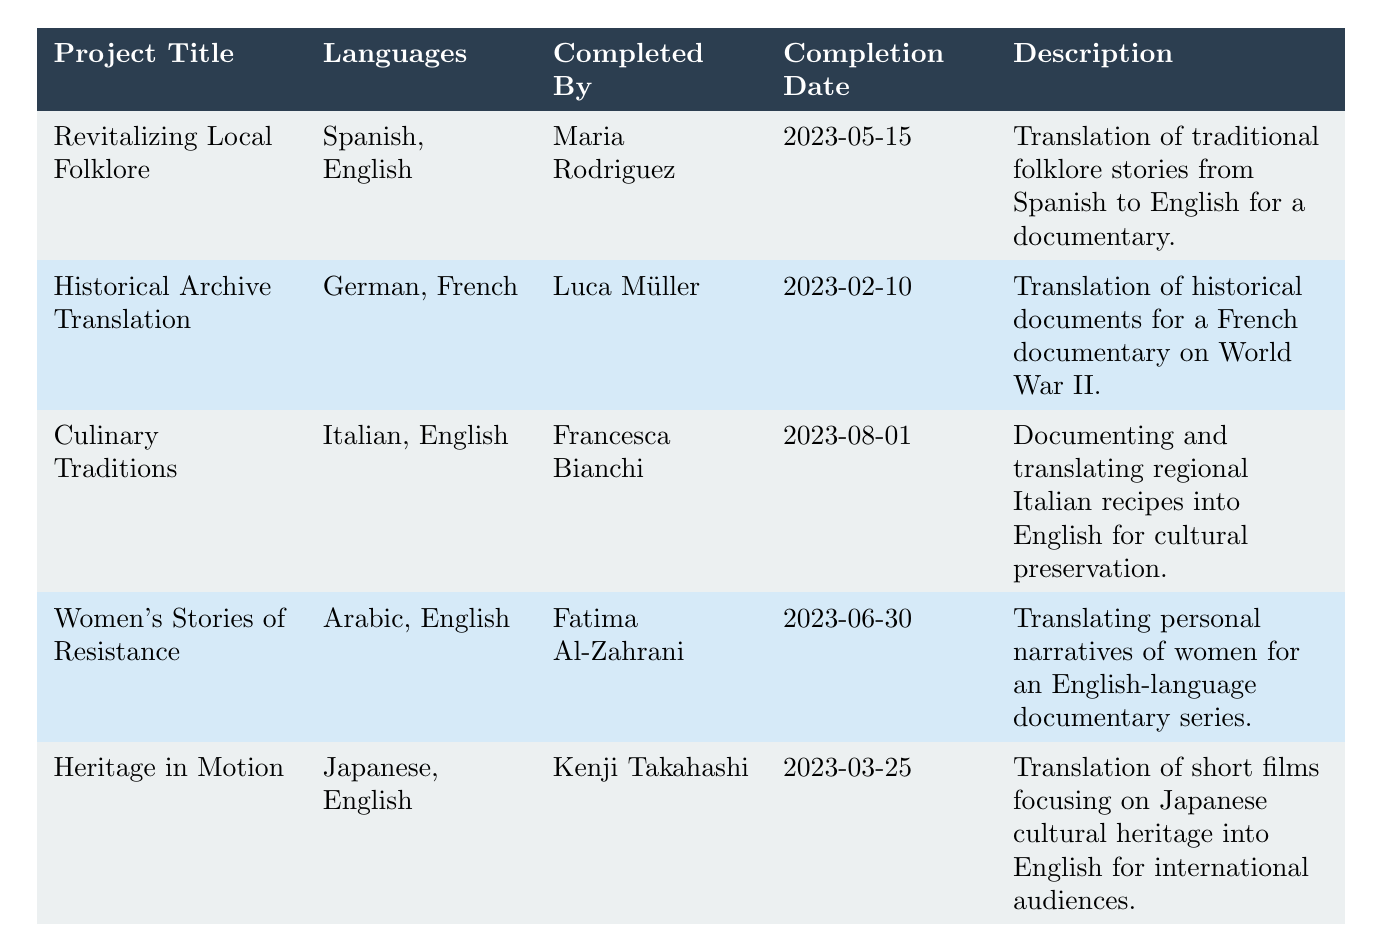What is the title of the project completed by Maria Rodriguez? The table lists the projects and the person who completed them. Maria Rodriguez's project is titled "Revitalizing Local Folklore," as indicated in her corresponding row.
Answer: Revitalizing Local Folklore How many translation projects involved translating into English? By examining the "Languages" column, we can count the projects that include "English" in their list. The relevant projects are "Revitalizing Local Folklore," "Culinary Traditions," "Women's Stories of Resistance," and "Heritage in Motion," totaling four projects.
Answer: 4 Was there a project that included both German and French translations? The table indicates that "Historical Archive Translation" included both German and French languages. This confirms that there was indeed a project translating into both of these languages.
Answer: Yes Who completed the "Culinary Traditions" project? Referring to the specific row for the "Culinary Traditions" project, we see that it was completed by Francesca Bianchi.
Answer: Francesca Bianchi Which project was completed most recently? To determine the most recent project, we compare the completion dates: May 15, June 30, August 1, February 10, and March 25. The latest date is August 1, which corresponds to the "Culinary Traditions" project.
Answer: Culinary Traditions How many different language pairs are represented in the table? The distinct language pairs from the table are: Spanish-English, German-French, Italian-English, Arabic-English, and Japanese-English. This is a total of five distinct pairs.
Answer: 5 Did Kenji Takahashi translate any project related to Japanese culture? The project "Heritage in Motion" indicates that Kenji Takahashi translated short films focusing on Japanese cultural heritage, making it true that he worked on a project related to Japanese culture.
Answer: Yes What is the completion date of the "Historical Archive Translation" project? The completion date is directly listed in the row for "Historical Archive Translation," where it shows as February 10, 2023.
Answer: 2023-02-10 List the names of the translators who worked on projects that included English translations. The translators for the projects with English included are Maria Rodriguez, Francesca Bianchi, Fatima Al-Zahrani, and Kenji Takahashi. To compile this, we check each project for the presence of English in the languages translated.
Answer: Maria Rodriguez, Francesca Bianchi, Fatima Al-Zahrani, Kenji Takahashi 